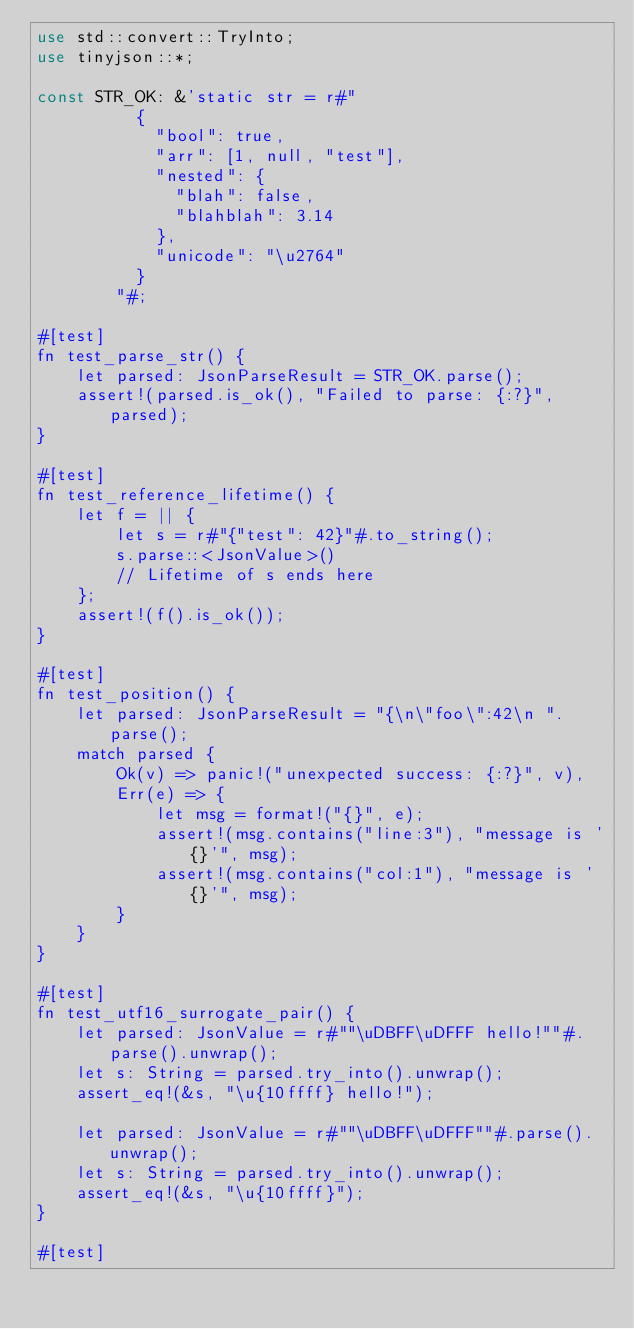Convert code to text. <code><loc_0><loc_0><loc_500><loc_500><_Rust_>use std::convert::TryInto;
use tinyjson::*;

const STR_OK: &'static str = r#"
          {
            "bool": true,
            "arr": [1, null, "test"],
            "nested": {
              "blah": false,
              "blahblah": 3.14
            },
            "unicode": "\u2764"
          }
        "#;

#[test]
fn test_parse_str() {
    let parsed: JsonParseResult = STR_OK.parse();
    assert!(parsed.is_ok(), "Failed to parse: {:?}", parsed);
}

#[test]
fn test_reference_lifetime() {
    let f = || {
        let s = r#"{"test": 42}"#.to_string();
        s.parse::<JsonValue>()
        // Lifetime of s ends here
    };
    assert!(f().is_ok());
}

#[test]
fn test_position() {
    let parsed: JsonParseResult = "{\n\"foo\":42\n ".parse();
    match parsed {
        Ok(v) => panic!("unexpected success: {:?}", v),
        Err(e) => {
            let msg = format!("{}", e);
            assert!(msg.contains("line:3"), "message is '{}'", msg);
            assert!(msg.contains("col:1"), "message is '{}'", msg);
        }
    }
}

#[test]
fn test_utf16_surrogate_pair() {
    let parsed: JsonValue = r#""\uDBFF\uDFFF hello!""#.parse().unwrap();
    let s: String = parsed.try_into().unwrap();
    assert_eq!(&s, "\u{10ffff} hello!");

    let parsed: JsonValue = r#""\uDBFF\uDFFF""#.parse().unwrap();
    let s: String = parsed.try_into().unwrap();
    assert_eq!(&s, "\u{10ffff}");
}

#[test]</code> 